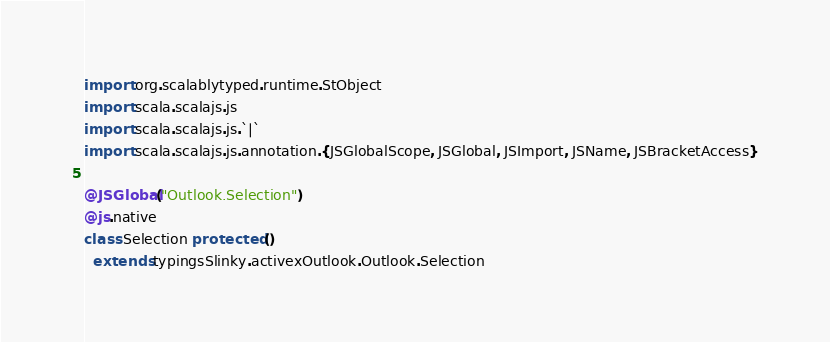Convert code to text. <code><loc_0><loc_0><loc_500><loc_500><_Scala_>
import org.scalablytyped.runtime.StObject
import scala.scalajs.js
import scala.scalajs.js.`|`
import scala.scalajs.js.annotation.{JSGlobalScope, JSGlobal, JSImport, JSName, JSBracketAccess}

@JSGlobal("Outlook.Selection")
@js.native
class Selection protected ()
  extends typingsSlinky.activexOutlook.Outlook.Selection
</code> 